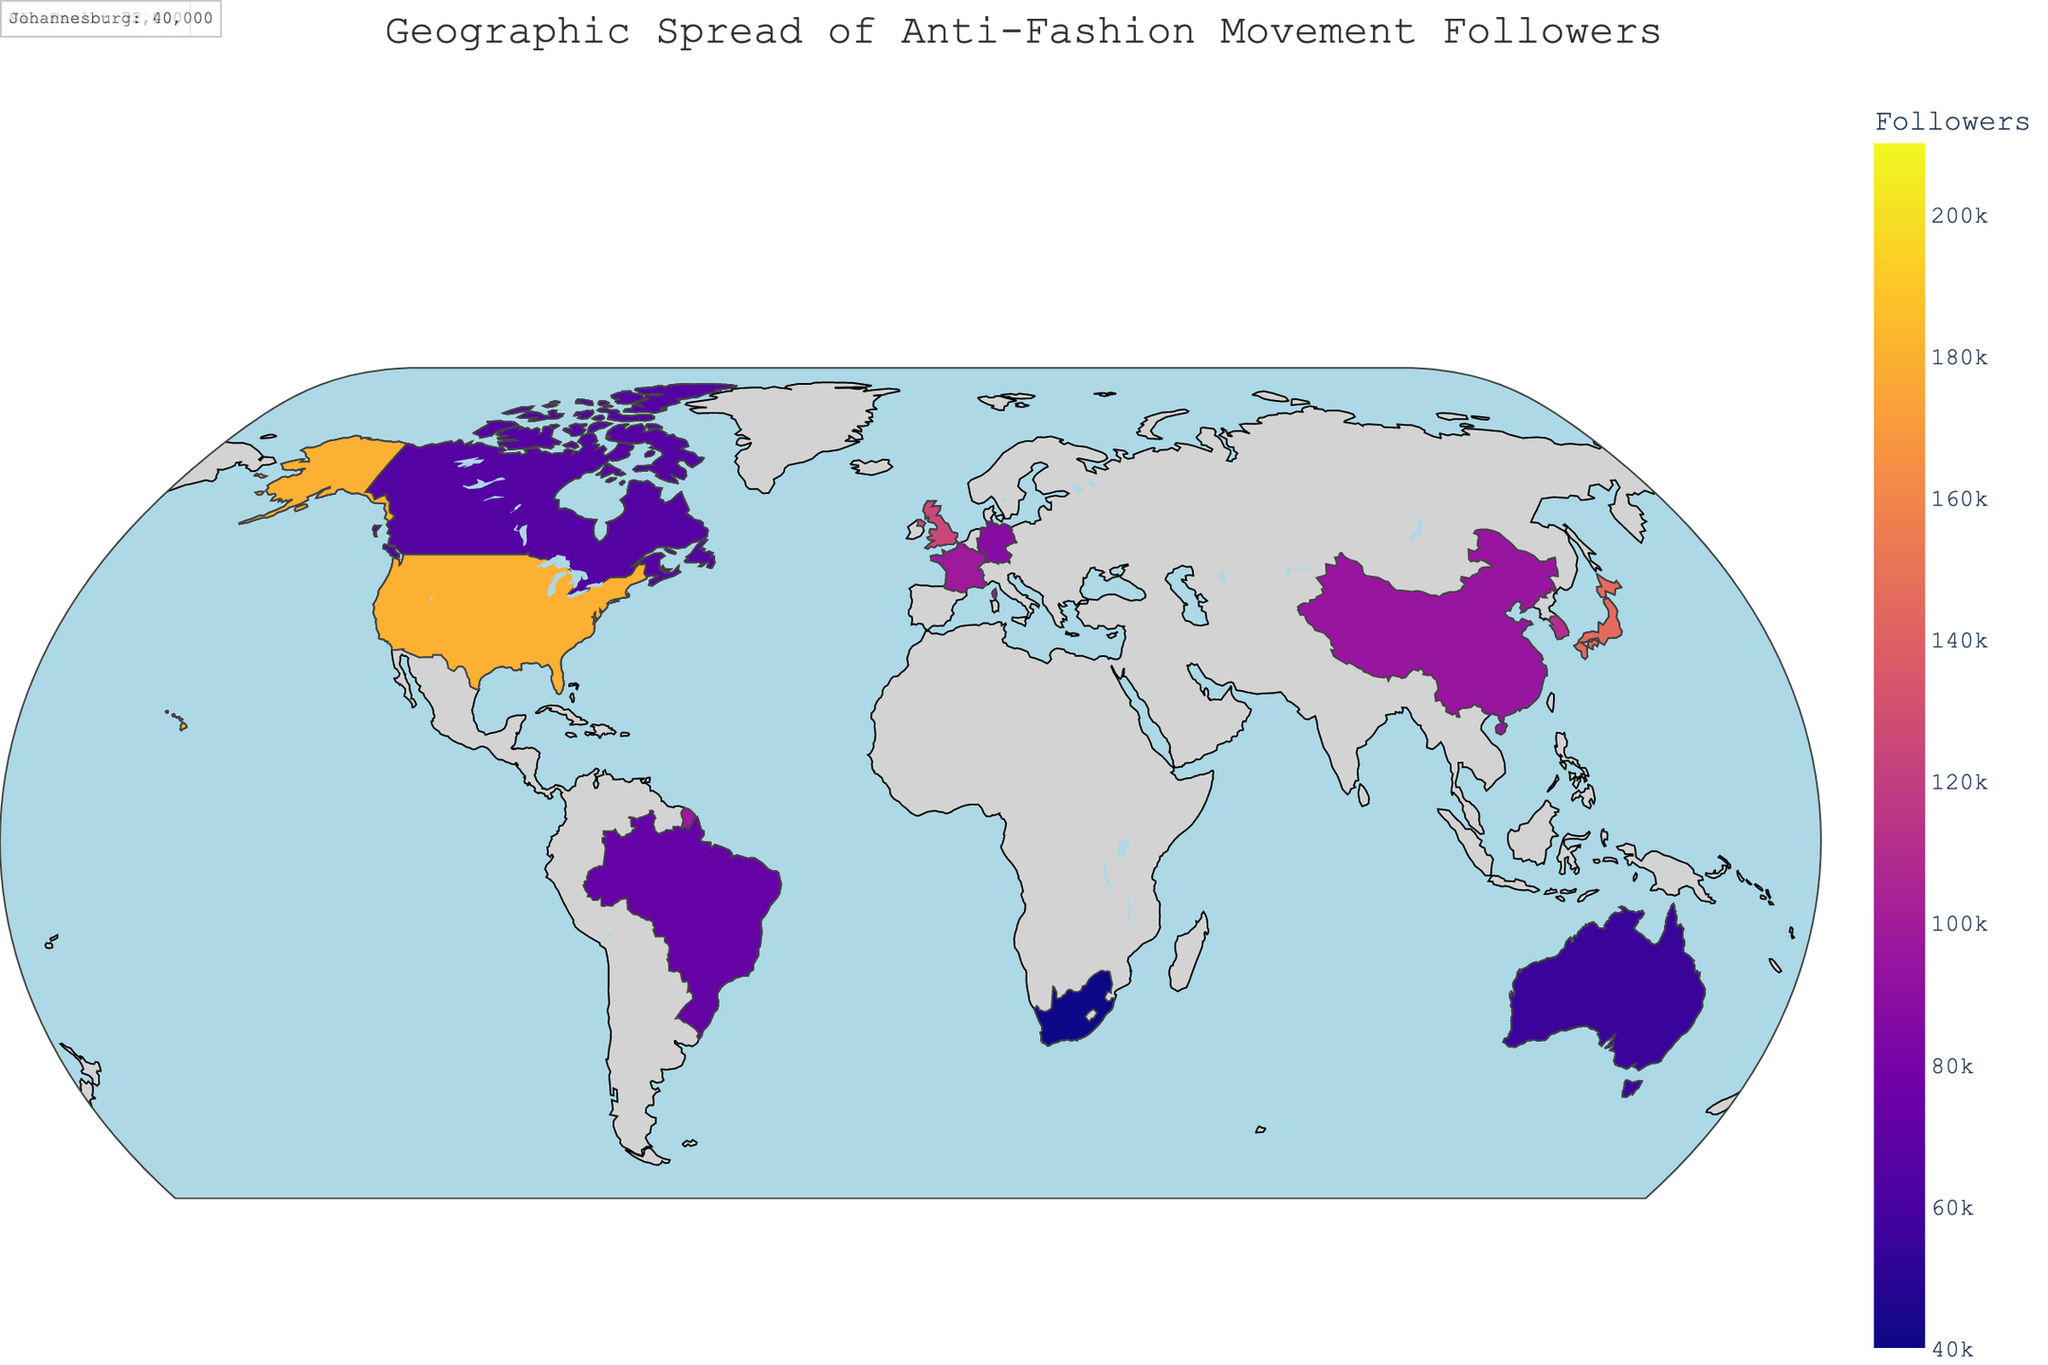What's the title of the plot? The title of the plot is displayed at the top center of the figure. By reading the text, you can identify the title.
Answer: Geographic Spread of Anti-Fashion Movement Followers Which continent has the most cities represented in the plot? By counting the number of cities listed for each continent, it's possible to see which one has the highest number. Europe has three cities (London, Paris, Berlin), North America has three (New York, Los Angeles, Toronto), Asia has three (Tokyo, Seoul, Shanghai), while other continents have fewer cities.
Answer: Europe, North America, and Asia (tie) Which city has the highest number of anti-fashion movement followers, and how many? Look at the data points for each city and identify the one with the highest value for anti-fashion followers. In the plot, New York has the highest value with 210,000 followers.
Answer: New York, 210,000 What's the total number of anti-fashion followers in Europe? Sum the number of followers for all European cities. The followers in Europe are: London (125,000), Paris (98,000), Berlin (87,000). Thus, 125,000 + 98,000 + 87,000 = 310,000 followers.
Answer: 310,000 Which continent has the lowest number of anti-fashion followers, and what is that number? By comparing the total followers for each continent, it's evident that Africa has the lowest number with Johannesburg having 40,000 followers.
Answer: Africa, 40,000 How does the number of followers in Tokyo compare to Seoul? By looking at the follower numbers in Tokyo and Seoul, Tokyo has 145,000 followers while Seoul has 110,000 followers. Thus, Tokyo has more followers.
Answer: Tokyo has more followers Which city in North America has the least anti-fashion followers, and how many? Among the North American cities, compare the follower numbers to identify the city with the least followers. Toronto has the least with 65,000 followers.
Answer: Toronto, 65,000 What is the difference in the number of followers between New York and Los Angeles? By subtracting the number of followers in Los Angeles from those in New York, the difference can be found. New York has 210,000 followers, and Los Angeles has 180,000 followers. So, 210,000 - 180,000 = 30,000.
Answer: 30,000 What's the average number of anti-fashion followers in Asia? Sum the followers in the Asian cities and divide by the number of cities. The followers in Asia are: Tokyo (145,000), Seoul (110,000), Shanghai (95,000). So, (145,000 + 110,000 + 95,000) / 3 = 350,000 / 3 = approximately 116,667.
Answer: 116,667 Which continent has the most diverse range of follower numbers? Examine the range of follower numbers within each continent and identify the one with the widest range. Asia (Tokyo: 145,000, Seoul: 110,000, Shanghai: 95,000) has a range of 145,000 - 95,000 = 50,000, Europe (London: 125,000, Paris: 98,000, Berlin: 87,000) has a range of 125,000 - 87,000 = 38,000. North America has the widest range: New York (210,000) - Toronto (65,000) = 145,000.
Answer: North America 